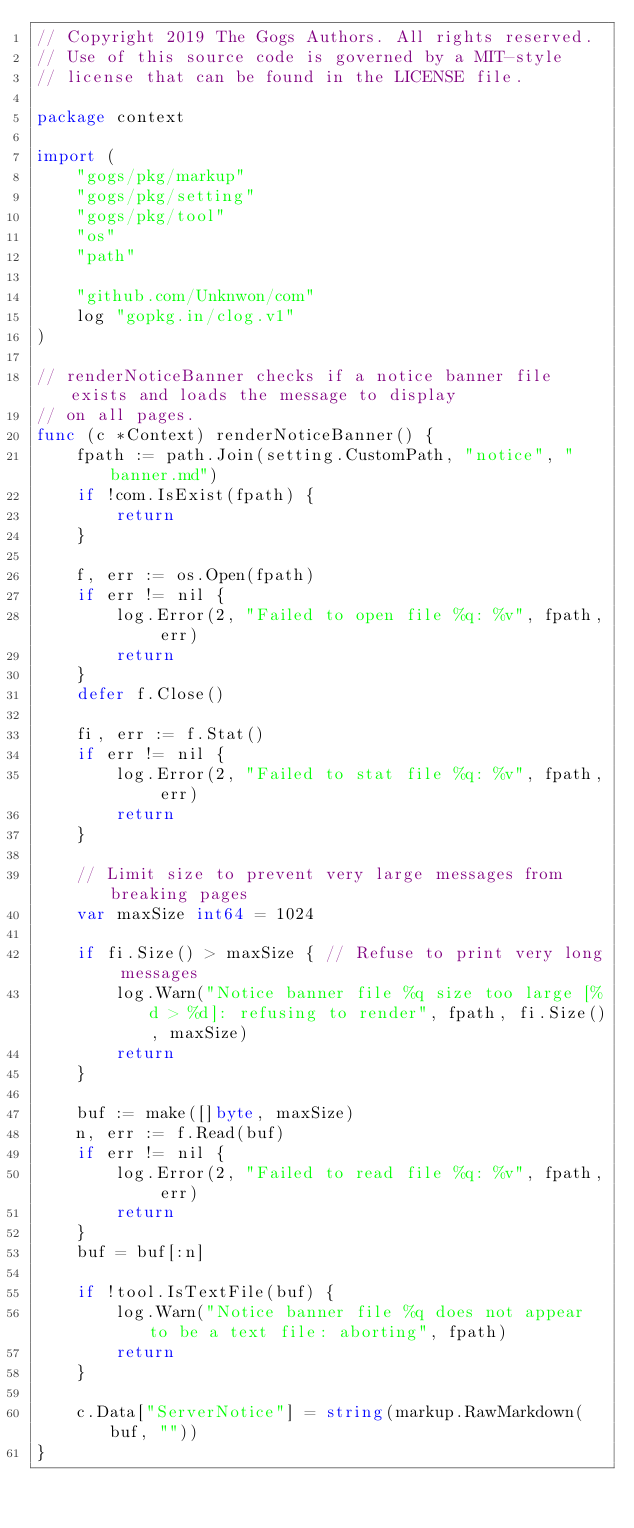Convert code to text. <code><loc_0><loc_0><loc_500><loc_500><_Go_>// Copyright 2019 The Gogs Authors. All rights reserved.
// Use of this source code is governed by a MIT-style
// license that can be found in the LICENSE file.

package context

import (
	"gogs/pkg/markup"
	"gogs/pkg/setting"
	"gogs/pkg/tool"
	"os"
	"path"

	"github.com/Unknwon/com"
	log "gopkg.in/clog.v1"
)

// renderNoticeBanner checks if a notice banner file exists and loads the message to display
// on all pages.
func (c *Context) renderNoticeBanner() {
	fpath := path.Join(setting.CustomPath, "notice", "banner.md")
	if !com.IsExist(fpath) {
		return
	}

	f, err := os.Open(fpath)
	if err != nil {
		log.Error(2, "Failed to open file %q: %v", fpath, err)
		return
	}
	defer f.Close()

	fi, err := f.Stat()
	if err != nil {
		log.Error(2, "Failed to stat file %q: %v", fpath, err)
		return
	}

	// Limit size to prevent very large messages from breaking pages
	var maxSize int64 = 1024

	if fi.Size() > maxSize { // Refuse to print very long messages
		log.Warn("Notice banner file %q size too large [%d > %d]: refusing to render", fpath, fi.Size(), maxSize)
		return
	}

	buf := make([]byte, maxSize)
	n, err := f.Read(buf)
	if err != nil {
		log.Error(2, "Failed to read file %q: %v", fpath, err)
		return
	}
	buf = buf[:n]

	if !tool.IsTextFile(buf) {
		log.Warn("Notice banner file %q does not appear to be a text file: aborting", fpath)
		return
	}

	c.Data["ServerNotice"] = string(markup.RawMarkdown(buf, ""))
}
</code> 